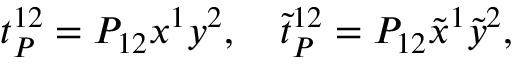<formula> <loc_0><loc_0><loc_500><loc_500>t _ { P } ^ { 1 2 } = P _ { 1 2 } x ^ { 1 } y ^ { 2 } , \quad \tilde { t } _ { P } ^ { 1 2 } = P _ { 1 2 } \tilde { x } ^ { 1 } \tilde { y } ^ { 2 } ,</formula> 